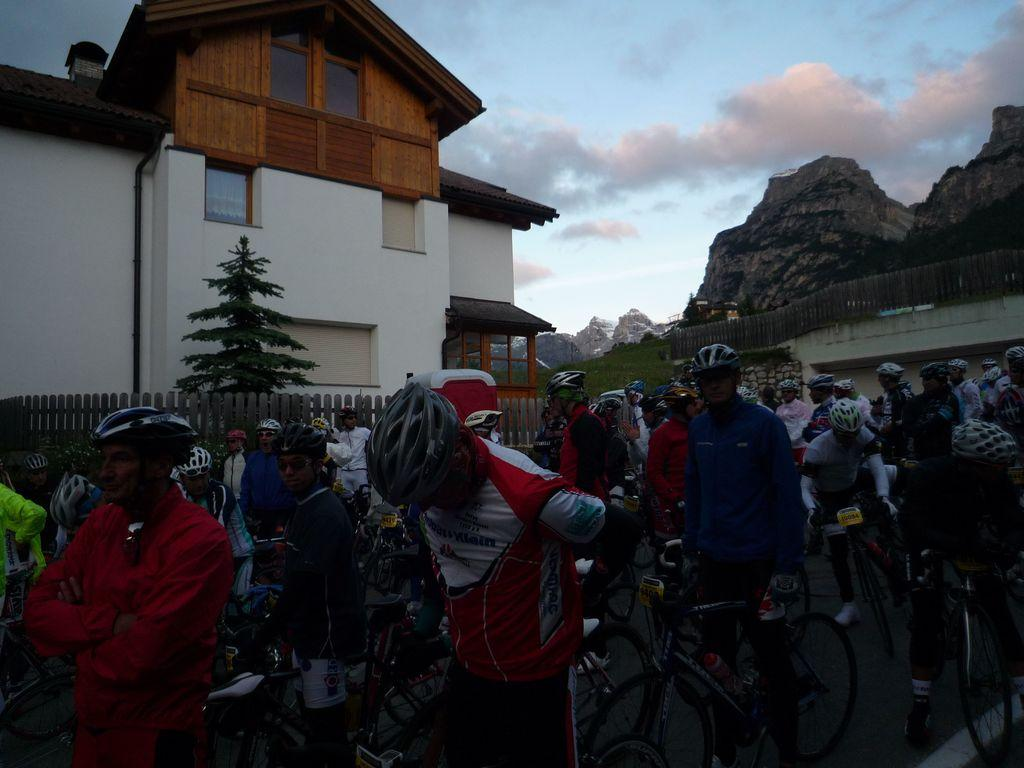What are the people in the image doing? The people in the image are standing with their cycles. What can be seen in the background of the image? There is a tree and a house in the background of the image. What is visible at the top of the image? The sky is visible in the image. What shape is the playground in the image? There is no playground present in the image. What type of land can be seen in the image? The image does not provide information about the type of land; it only shows people with their cycles, a tree, a house, and the sky. 